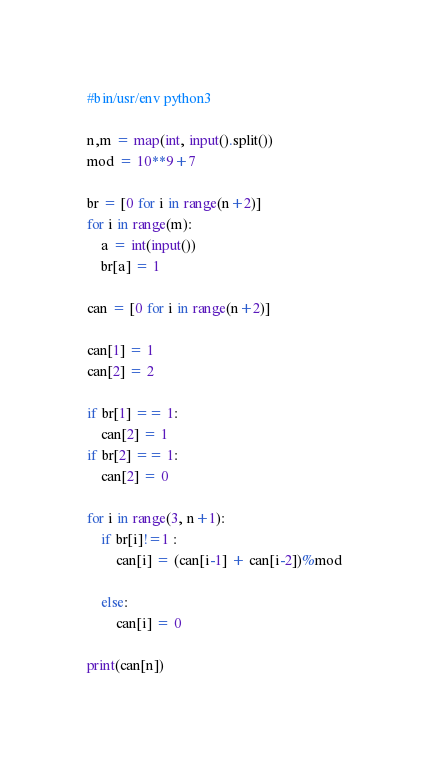<code> <loc_0><loc_0><loc_500><loc_500><_Python_>#bin/usr/env python3

n,m = map(int, input().split())
mod = 10**9+7

br = [0 for i in range(n+2)]
for i in range(m):
    a = int(input())
    br[a] = 1

can = [0 for i in range(n+2)]

can[1] = 1
can[2] = 2

if br[1] == 1:
    can[2] = 1
if br[2] == 1:
    can[2] = 0

for i in range(3, n+1):
    if br[i]!=1 :
        can[i] = (can[i-1] + can[i-2])%mod
    
    else:
        can[i] = 0

print(can[n])


</code> 